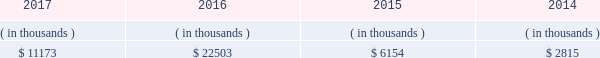Is expected to begin by late-2018 , after the necessary information technology infrastructure is in place .
Entergy louisiana proposed to recover the cost of ami through the implementation of a customer charge , net of certain benefits , phased in over the period 2019 through 2022 .
The parties reached an uncontested stipulation permitting implementation of entergy louisiana 2019s proposed ami system , with modifications to the proposed customer charge .
In july 2017 the lpsc approved the stipulation .
Entergy louisiana expects to recover the undepreciated balance of its existing meters through a regulatory asset at current depreciation rates .
Sources of capital entergy louisiana 2019s sources to meet its capital requirements include : 2022 internally generated funds ; 2022 cash on hand ; 2022 debt or preferred membership interest issuances ; and 2022 bank financing under new or existing facilities .
Entergy louisiana may refinance , redeem , or otherwise retire debt prior to maturity , to the extent market conditions and interest rates are favorable .
All debt and common and preferred membership interest issuances by entergy louisiana require prior regulatory approval .
Preferred membership interest and debt issuances are also subject to issuance tests set forth in its bond indentures and other agreements .
Entergy louisiana has sufficient capacity under these tests to meet its foreseeable capital needs .
Entergy louisiana 2019s receivables from the money pool were as follows as of december 31 for each of the following years. .
See note 4 to the financial statements for a description of the money pool .
Entergy louisiana has a credit facility in the amount of $ 350 million scheduled to expire in august 2022 .
The credit facility allows entergy louisiana to issue letters of credit against $ 15 million of the borrowing capacity of the facility .
As of december 31 , 2017 , there were no cash borrowings and a $ 9.1 million letter of credit outstanding under the credit facility .
In addition , entergy louisiana is a party to an uncommitted letter of credit facility as a means to post collateral to support its obligations to miso . a0 as of december 31 , 2017 , a $ 29.7 million letter of credit was outstanding under entergy louisiana 2019s uncommitted letter of credit a0facility .
See note 4 to the financial statements for additional discussion of the credit facilities .
The entergy louisiana nuclear fuel company variable interest entities have two separate credit facilities , one in the amount of $ 105 million and one in the amount of $ 85 million , both scheduled to expire in may 2019 .
As of december 31 , 2017 , $ 65.7 million of loans were outstanding under the credit facility for the entergy louisiana river bend nuclear fuel company variable interest entity .
As of december 31 , 2017 , $ 43.5 million in letters of credit to support a like amount of commercial paper issued and $ 36.4 million in loans were outstanding under the entergy louisiana waterford nuclear fuel company variable interest entity credit facility .
See note 4 to the financial statements for additional discussion of the nuclear fuel company variable interest entity credit facilities .
Entergy louisiana , llc and subsidiaries management 2019s financial discussion and analysis .
What percent higher yields from the money pool in the years 2016 and 2017 , than the years 2014 and 2015? 
Computations: (((11173 + 22503) / (6154 + 2815)) - 1)
Answer: 2.75471. 